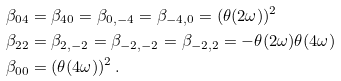Convert formula to latex. <formula><loc_0><loc_0><loc_500><loc_500>& \beta _ { 0 4 } = \beta _ { 4 0 } = \beta _ { 0 , - 4 } = \beta _ { - 4 , 0 } = ( \theta ( 2 \omega ) ) ^ { 2 } \\ & \beta _ { 2 2 } = \beta _ { 2 , - 2 } = \beta _ { - 2 , - 2 } = \beta _ { - 2 , 2 } = - \theta ( 2 \omega ) \theta ( 4 \omega ) \\ & \beta _ { 0 0 } = ( \theta ( 4 \omega ) ) ^ { 2 } \, .</formula> 